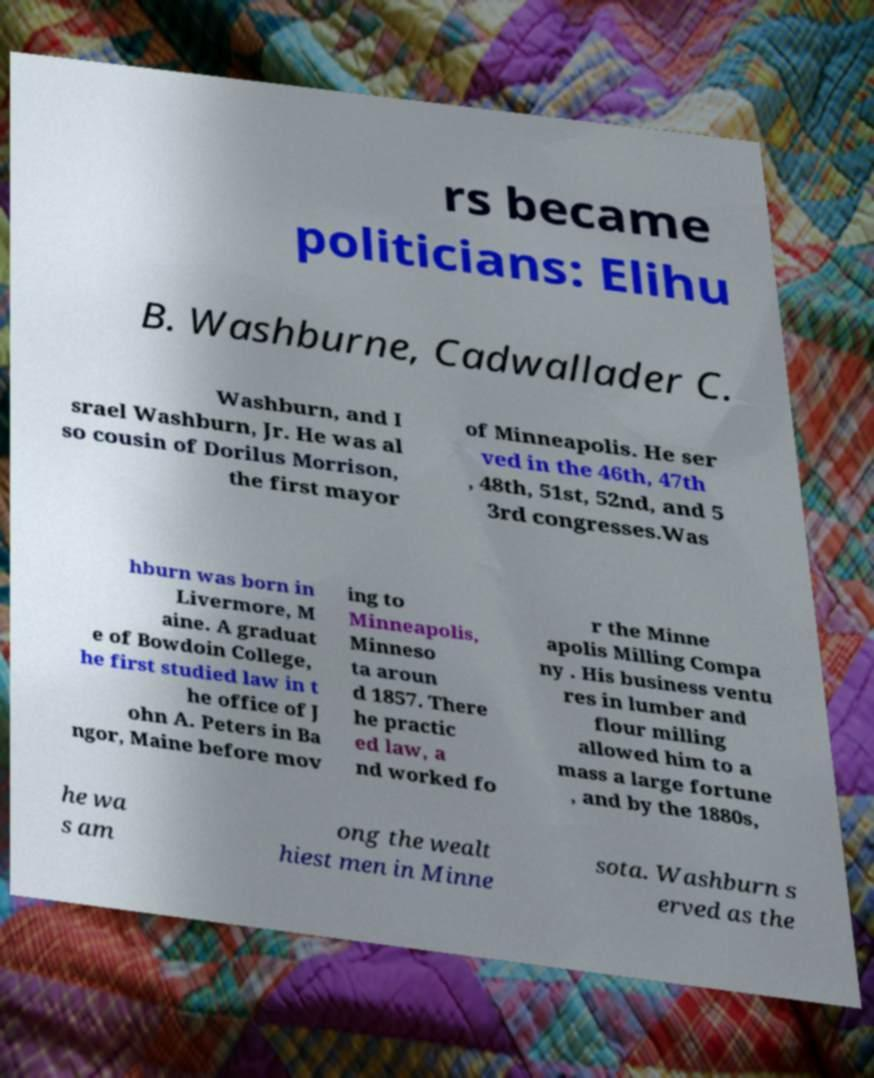Could you extract and type out the text from this image? rs became politicians: Elihu B. Washburne, Cadwallader C. Washburn, and I srael Washburn, Jr. He was al so cousin of Dorilus Morrison, the first mayor of Minneapolis. He ser ved in the 46th, 47th , 48th, 51st, 52nd, and 5 3rd congresses.Was hburn was born in Livermore, M aine. A graduat e of Bowdoin College, he first studied law in t he office of J ohn A. Peters in Ba ngor, Maine before mov ing to Minneapolis, Minneso ta aroun d 1857. There he practic ed law, a nd worked fo r the Minne apolis Milling Compa ny . His business ventu res in lumber and flour milling allowed him to a mass a large fortune , and by the 1880s, he wa s am ong the wealt hiest men in Minne sota. Washburn s erved as the 